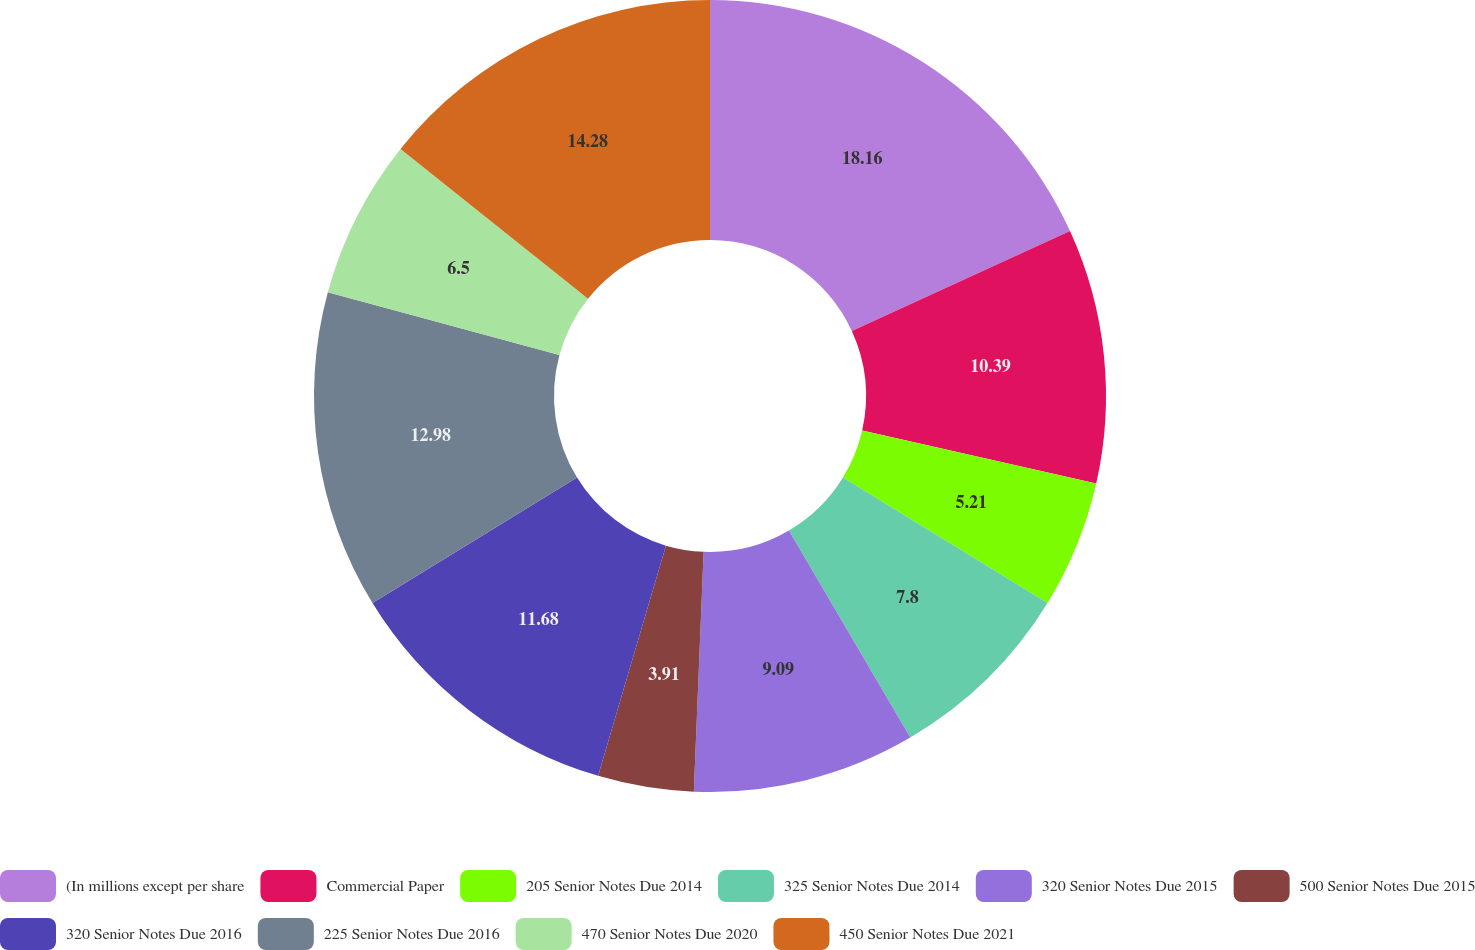<chart> <loc_0><loc_0><loc_500><loc_500><pie_chart><fcel>(In millions except per share<fcel>Commercial Paper<fcel>205 Senior Notes Due 2014<fcel>325 Senior Notes Due 2014<fcel>320 Senior Notes Due 2015<fcel>500 Senior Notes Due 2015<fcel>320 Senior Notes Due 2016<fcel>225 Senior Notes Due 2016<fcel>470 Senior Notes Due 2020<fcel>450 Senior Notes Due 2021<nl><fcel>18.16%<fcel>10.39%<fcel>5.21%<fcel>7.8%<fcel>9.09%<fcel>3.91%<fcel>11.68%<fcel>12.98%<fcel>6.5%<fcel>14.28%<nl></chart> 